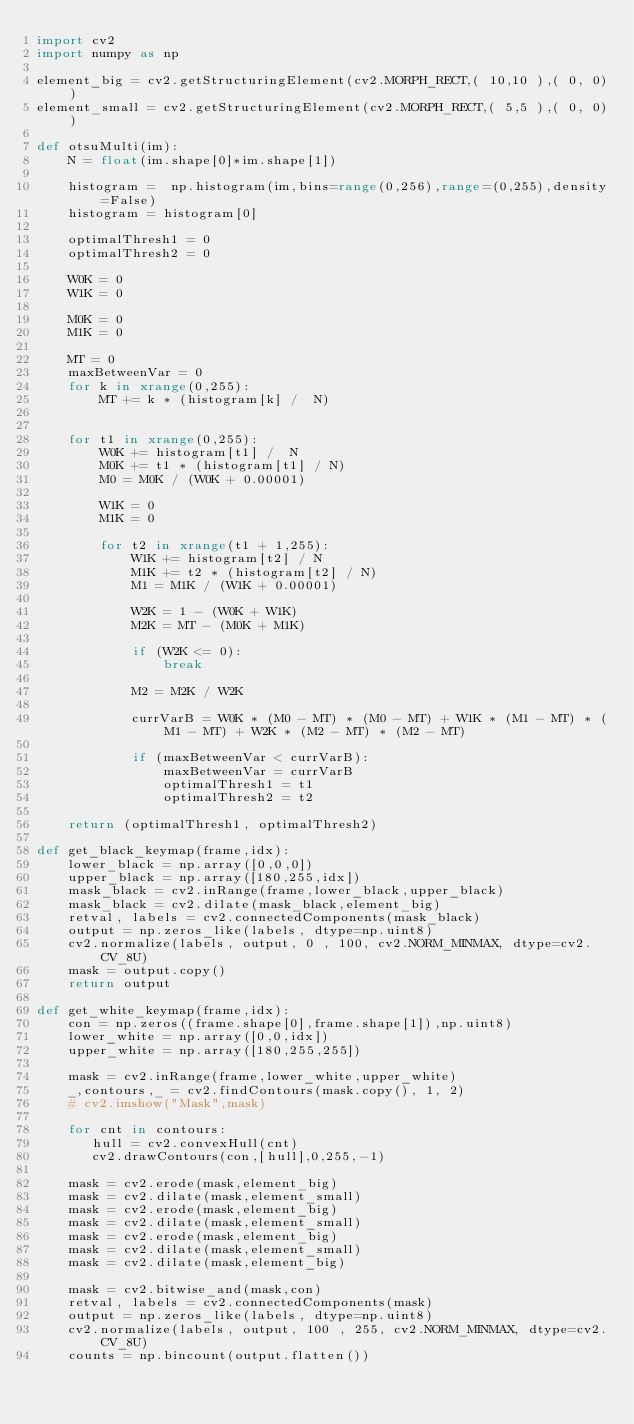<code> <loc_0><loc_0><loc_500><loc_500><_Python_>import cv2
import numpy as np

element_big = cv2.getStructuringElement(cv2.MORPH_RECT,( 10,10 ),( 0, 0))
element_small = cv2.getStructuringElement(cv2.MORPH_RECT,( 5,5 ),( 0, 0))

def otsuMulti(im):
    N = float(im.shape[0]*im.shape[1])

    histogram =  np.histogram(im,bins=range(0,256),range=(0,255),density=False)
    histogram = histogram[0]

    optimalThresh1 = 0
    optimalThresh2 = 0

    W0K = 0
    W1K = 0

    M0K = 0
    M1K = 0

    MT = 0
    maxBetweenVar = 0
    for k in xrange(0,255):
        MT += k * (histogram[k] /  N)


    for t1 in xrange(0,255):
        W0K += histogram[t1] /  N
        M0K += t1 * (histogram[t1] / N)
        M0 = M0K / (W0K + 0.00001)

        W1K = 0
        M1K = 0

        for t2 in xrange(t1 + 1,255):
            W1K += histogram[t2] / N
            M1K += t2 * (histogram[t2] / N)
            M1 = M1K / (W1K + 0.00001)

            W2K = 1 - (W0K + W1K)
            M2K = MT - (M0K + M1K)

            if (W2K <= 0):
                break

            M2 = M2K / W2K

            currVarB = W0K * (M0 - MT) * (M0 - MT) + W1K * (M1 - MT) * (M1 - MT) + W2K * (M2 - MT) * (M2 - MT)

            if (maxBetweenVar < currVarB):
                maxBetweenVar = currVarB
                optimalThresh1 = t1
                optimalThresh2 = t2

    return (optimalThresh1, optimalThresh2)

def get_black_keymap(frame,idx):
    lower_black = np.array([0,0,0])
    upper_black = np.array([180,255,idx])
    mask_black = cv2.inRange(frame,lower_black,upper_black)
    mask_black = cv2.dilate(mask_black,element_big)
    retval, labels = cv2.connectedComponents(mask_black)
    output = np.zeros_like(labels, dtype=np.uint8)
    cv2.normalize(labels, output, 0 , 100, cv2.NORM_MINMAX, dtype=cv2.CV_8U)
    mask = output.copy()
    return output

def get_white_keymap(frame,idx):
    con = np.zeros((frame.shape[0],frame.shape[1]),np.uint8)
    lower_white = np.array([0,0,idx])
    upper_white = np.array([180,255,255])

    mask = cv2.inRange(frame,lower_white,upper_white)
    _,contours,_ = cv2.findContours(mask.copy(), 1, 2)
    # cv2.imshow("Mask",mask)

    for cnt in contours:
       hull = cv2.convexHull(cnt)
       cv2.drawContours(con,[hull],0,255,-1)

    mask = cv2.erode(mask,element_big)
    mask = cv2.dilate(mask,element_small)
    mask = cv2.erode(mask,element_big)
    mask = cv2.dilate(mask,element_small)
    mask = cv2.erode(mask,element_big)
    mask = cv2.dilate(mask,element_small)
    mask = cv2.dilate(mask,element_big)

    mask = cv2.bitwise_and(mask,con)
    retval, labels = cv2.connectedComponents(mask)
    output = np.zeros_like(labels, dtype=np.uint8)
    cv2.normalize(labels, output, 100 , 255, cv2.NORM_MINMAX, dtype=cv2.CV_8U)
    counts = np.bincount(output.flatten())</code> 